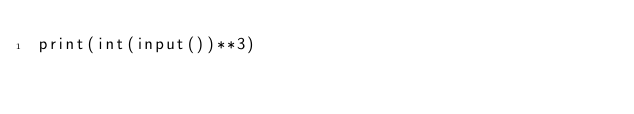Convert code to text. <code><loc_0><loc_0><loc_500><loc_500><_Python_>print(int(input())**3)
</code> 